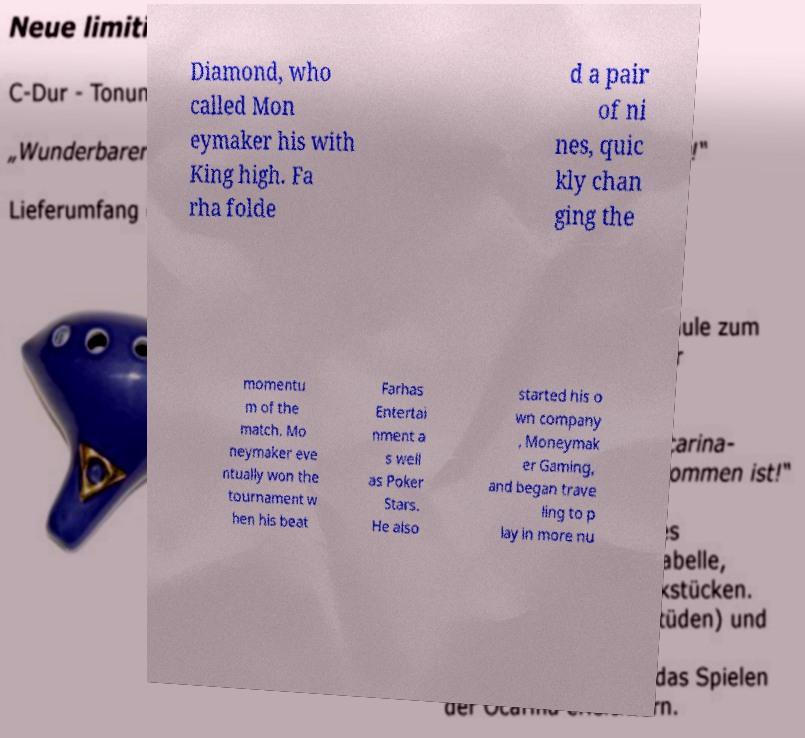I need the written content from this picture converted into text. Can you do that? Diamond, who called Mon eymaker his with King high. Fa rha folde d a pair of ni nes, quic kly chan ging the momentu m of the match. Mo neymaker eve ntually won the tournament w hen his beat Farhas Entertai nment a s well as Poker Stars. He also started his o wn company , Moneymak er Gaming, and began trave ling to p lay in more nu 